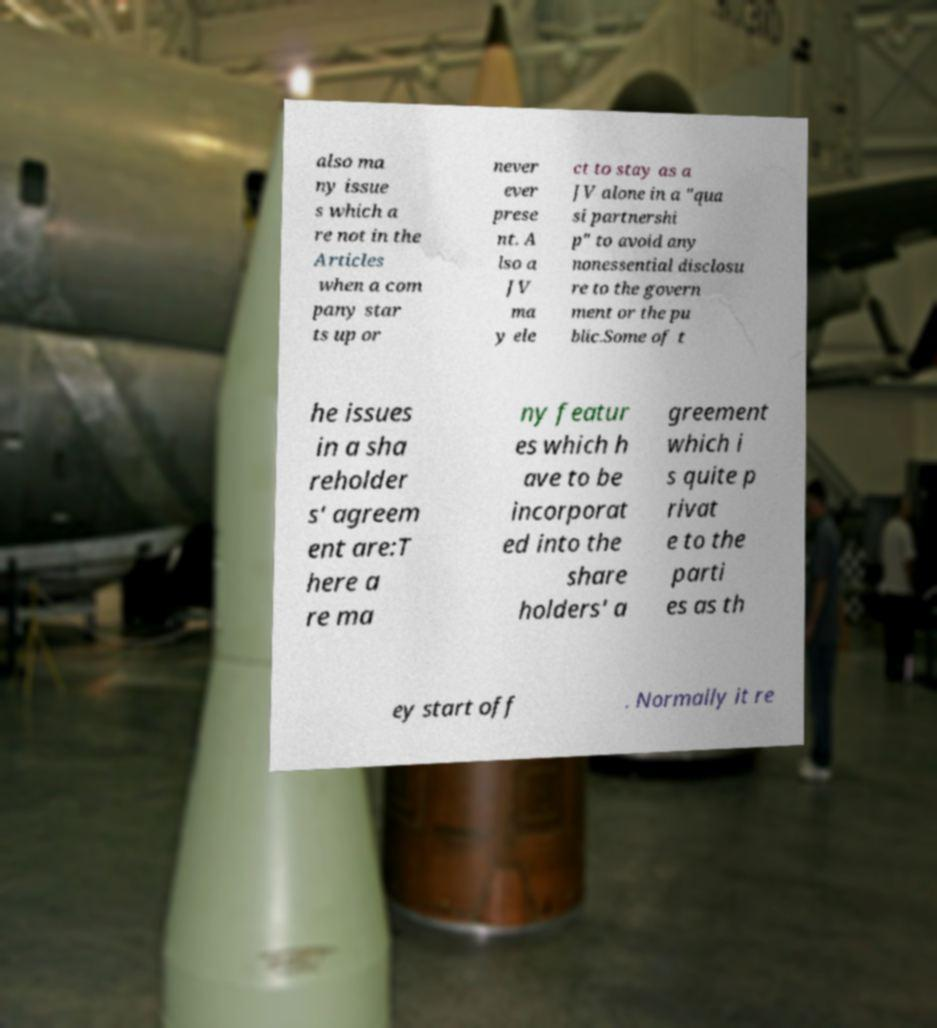For documentation purposes, I need the text within this image transcribed. Could you provide that? also ma ny issue s which a re not in the Articles when a com pany star ts up or never ever prese nt. A lso a JV ma y ele ct to stay as a JV alone in a "qua si partnershi p" to avoid any nonessential disclosu re to the govern ment or the pu blic.Some of t he issues in a sha reholder s' agreem ent are:T here a re ma ny featur es which h ave to be incorporat ed into the share holders' a greement which i s quite p rivat e to the parti es as th ey start off . Normally it re 